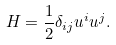<formula> <loc_0><loc_0><loc_500><loc_500>H = \frac { 1 } { 2 } \delta _ { i j } u ^ { i } u ^ { j } .</formula> 